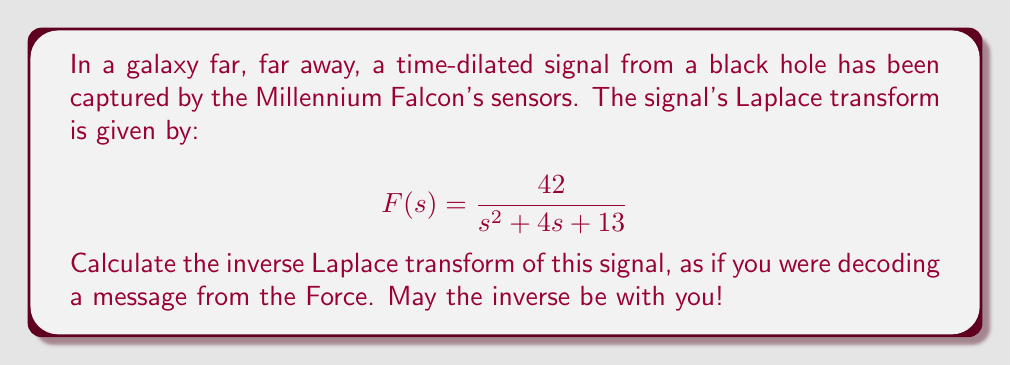Help me with this question. To find the inverse Laplace transform, we'll use the following approach:

1) First, we recognize that this is in the form of:

   $$\frac{A}{s^2 + 2as + b^2}$$

   where $A = 42$, $2a = 4$ (so $a = 2$), and $b^2 = 13$.

2) The inverse Laplace transform of this form is:

   $$Ae^{-at}\frac{\sin(bt)}{b}$$

   where $b = \sqrt{b^2 - a^2}$

3) Let's calculate $b$:
   
   $b = \sqrt{13 - 2^2} = \sqrt{9} = 3$

4) Now we can substitute our values:

   $A = 42$
   $a = 2$
   $b = 3$

5) Plugging these into our inverse Laplace transform formula:

   $$42e^{-2t}\frac{\sin(3t)}{3}$$

6) Simplifying:

   $$14e^{-2t}\sin(3t)$$

This final expression represents our time-domain signal, emerging from the event horizon of mathematical transformation like a ship exiting hyperspace.
Answer: $$f(t) = 14e^{-2t}\sin(3t)$$ 